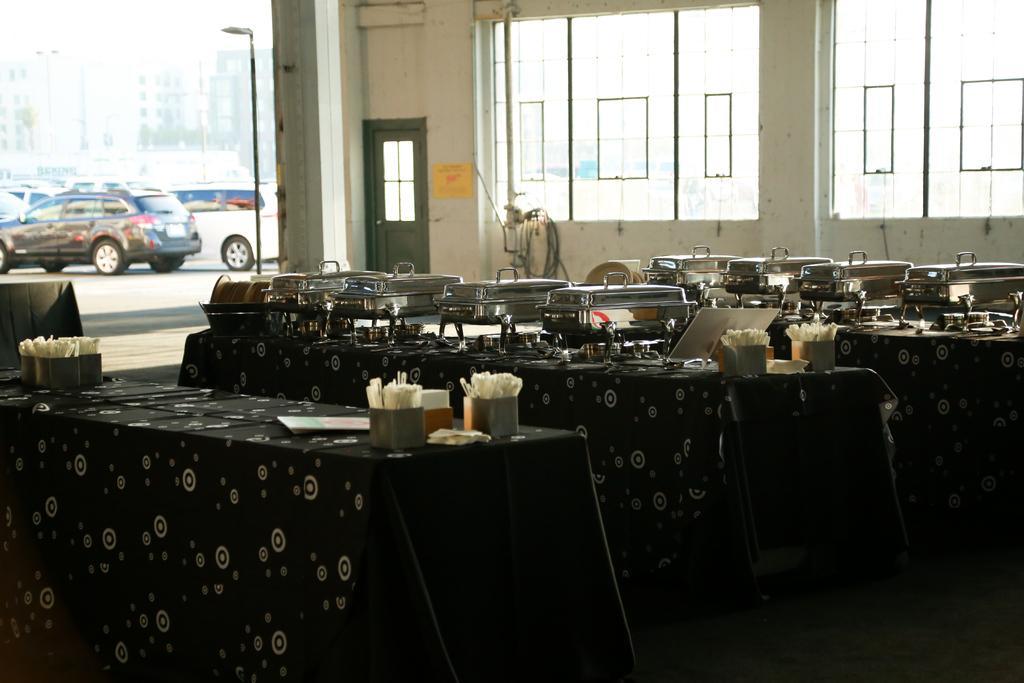Could you give a brief overview of what you see in this image? In this image we can see food buffets are kept on this table which is covered with a bed sheet cover. Here we can see a few cars which are parked in a parking space. 